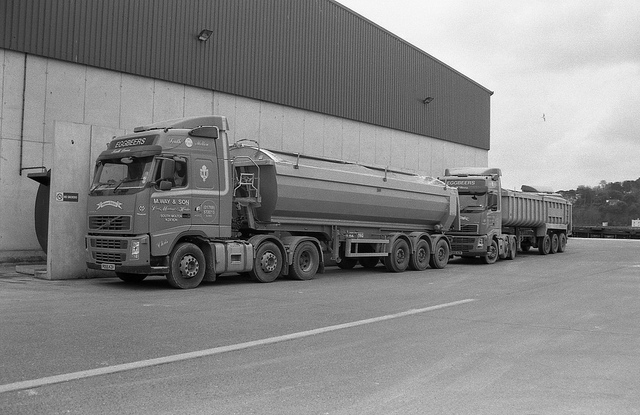<image>What is the proper term for several buses driving in tandem? It is unknown what the proper term for several buses driving in tandem is. It might be a convoy or fleet. What do these vehicles transport? I don't know exactly what these vehicles transport. It could be dirt, oil, fuel, gas, gravel or water. What is the proper term for several buses driving in tandem? It is unknown what is the proper term for several buses driving in tandem. It can be called articulated bus, convoy, fleet or driving. What do these vehicles transport? It is unknown what these vehicles transport. However, it can be fuel, gas, water, or dirt. 